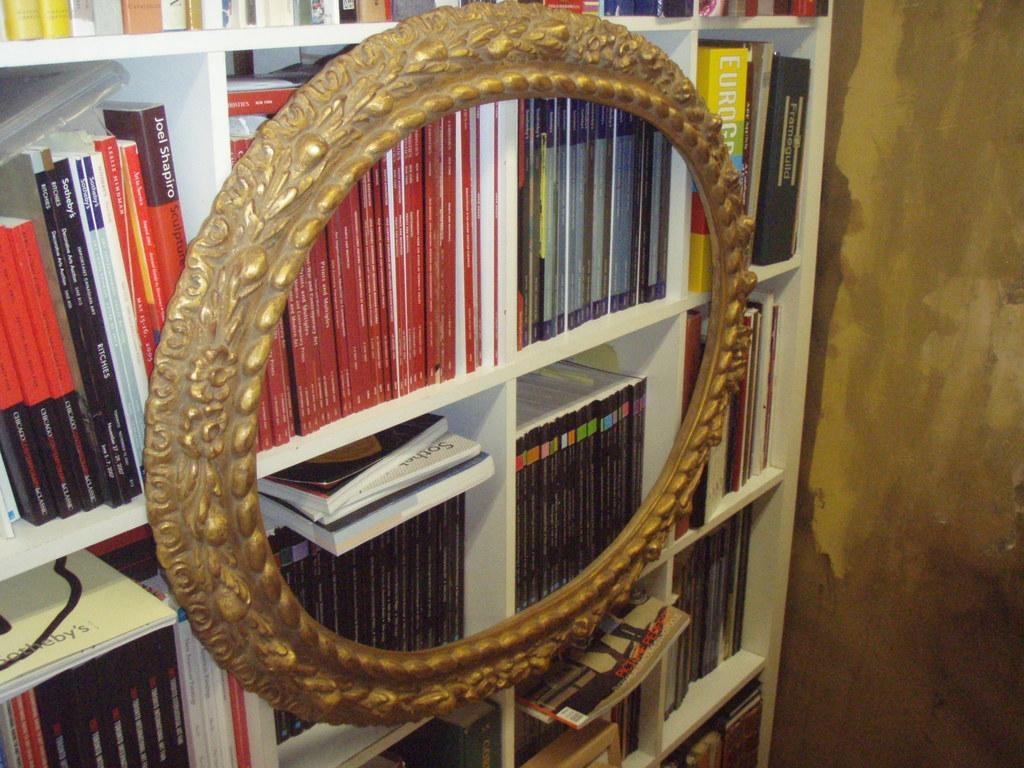What type of items can be seen on the shelves in the image? There are books on the shelves in the image. Is there anything else on the shelves besides books? Yes, there is an object on the shelves. What can be seen in the background of the image? There is a wall in the image. How many sisters are visible in the image? There are no sisters present in the image. What type of vegetable can be seen growing on the wall in the image? There are no vegetables visible in the image, and the wall does not have any vegetation growing on it. 